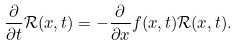<formula> <loc_0><loc_0><loc_500><loc_500>\frac { \partial } { \partial t } \mathcal { R } ( x , t ) = - \frac { \partial } { \partial x } f ( x , t ) \mathcal { R } ( x , t ) .</formula> 